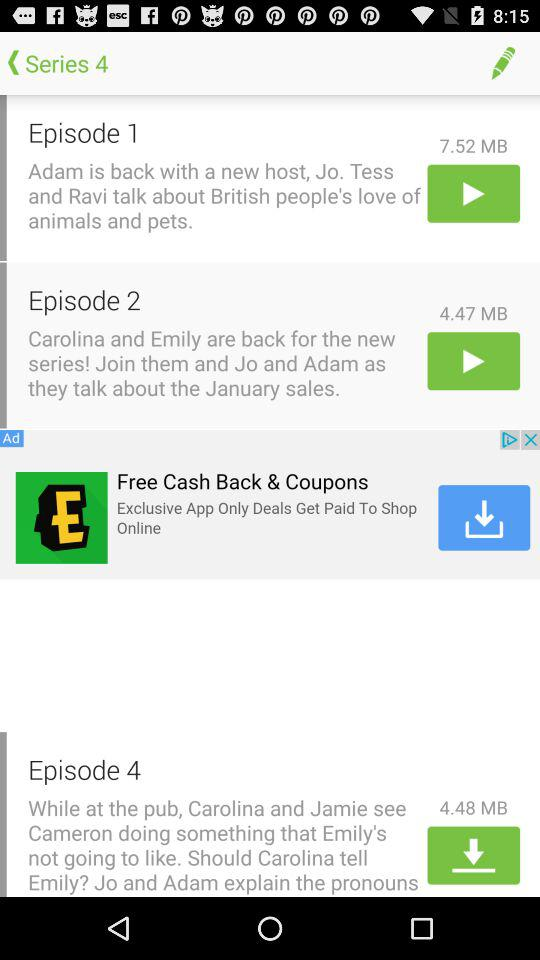How many MB is Episode 1? Episode 1 is 7.52 MB in size. 